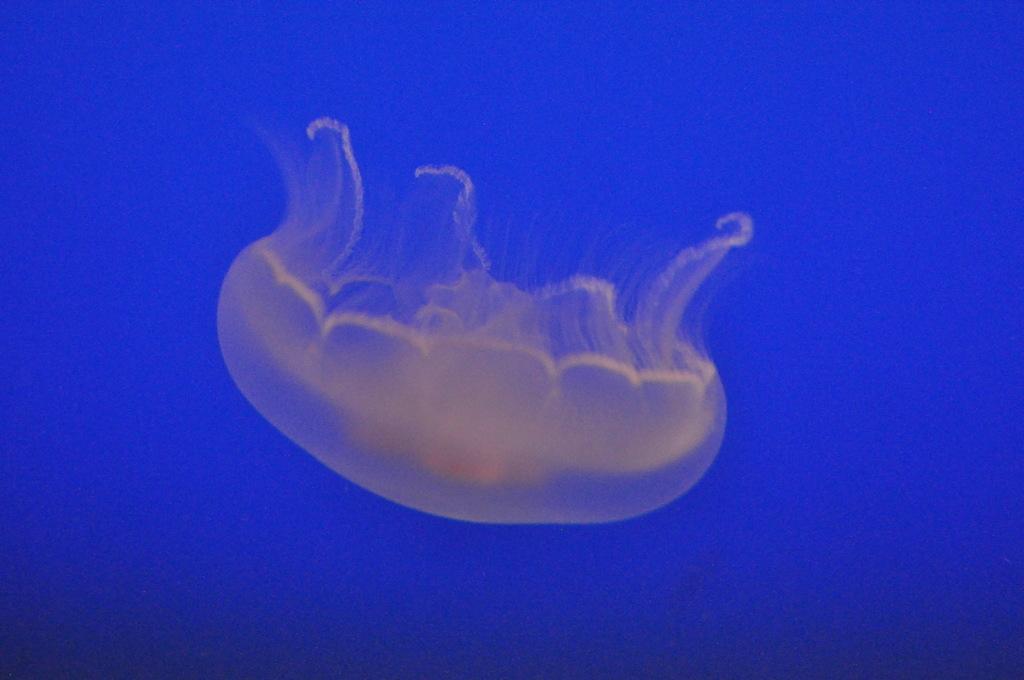How would you summarize this image in a sentence or two? Here we can see a jellyfish. In the background the image is in blue color. 